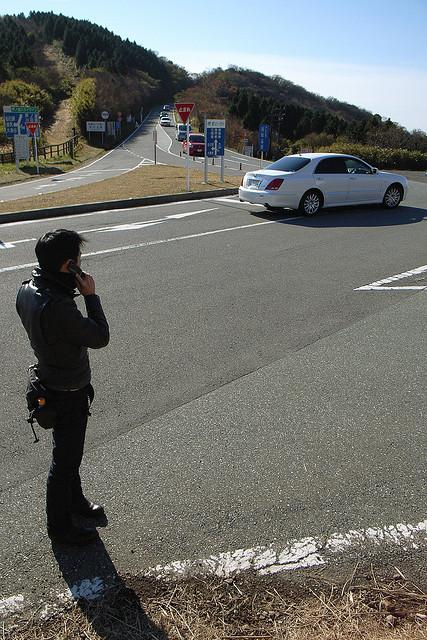What shape is the red sign? triangle 